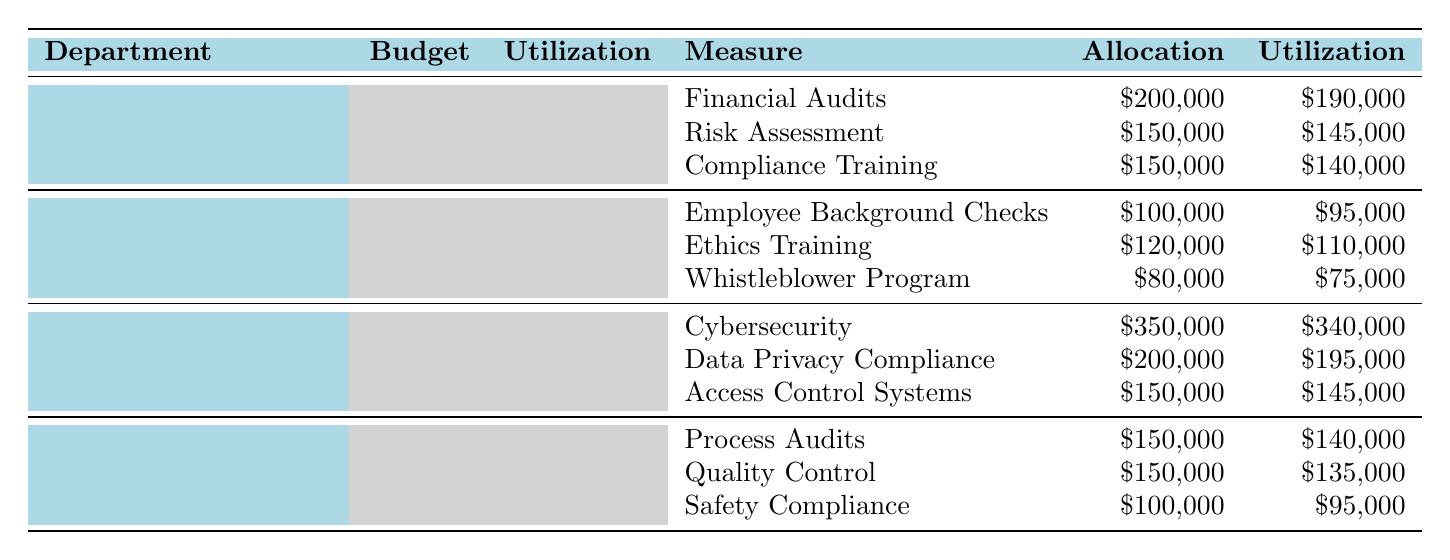What is the total budget allocation for the Finance department? The Finance department has a budget allocation of $500,000 as stated in the table.
Answer: $500,000 How much money has the Human Resources department utilized? The table indicates that the Human Resources department has utilized $280,000.
Answer: $280,000 What percentage of the Information Technology budget has been utilized? The utilization for Information Technology is $680,000 out of a budget allocation of $700,000. The percentage utilized is (680,000 / 700,000) * 100 = 97.14%.
Answer: 97.14% Which measure in the Operations department had the highest percentage of utilization? The measures are Process Audits (93.33%), Quality Control (90%), and Safety Compliance (95%). The measure with the highest utilization percentage is Process Audits.
Answer: Process Audits What is the total allocation for measures under the Human Resources department? Adding up the allocations: Employee Background Checks ($100,000) + Ethics Training ($120,000) + Whistleblower Program ($80,000) gives a total allocation of $300,000.
Answer: $300,000 Is the total utilization for the Finance department greater than that of the Operations department? The Finance department's utilization is $475,000, while Operations' is $370,000. Since $475,000 > $370,000, the statement is true.
Answer: Yes How much of the budget remains unutilized in the Information Technology department? The budget allocated is $700,000 and the utilized amount is $680,000. The remaining budget is $700,000 - $680,000 = $20,000.
Answer: $20,000 What is the combined allocation for Compliance-related measures across all departments? The Compliance-related measures are: Compliance Training in Finance ($150,000), Data Privacy Compliance in IT ($200,000), and Safety Compliance in Operations ($100,000). The total is $150,000 + $200,000 + $100,000 = $450,000.
Answer: $450,000 Which department has the lowest utilization rate? We calculate the utilization rates: Finance (95%), Human Resources (93.33%), Information Technology (97.14%), and Operations (92.5%). The lowest utilization rate belongs to Operations.
Answer: Operations What is the average allocation per measure for all departments combined? Each department has 3 measures, totaling 12 across 4 departments. The total allocation is $500,000 + $300,000 + $700,000 + $400,000 = $1,900,000. The average allocation per measure is $1,900,000 / 12 = $158,333.33.
Answer: $158,333.33 